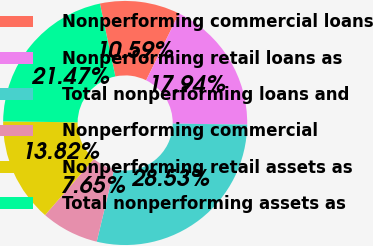Convert chart to OTSL. <chart><loc_0><loc_0><loc_500><loc_500><pie_chart><fcel>Nonperforming commercial loans<fcel>Nonperforming retail loans as<fcel>Total nonperforming loans and<fcel>Nonperforming commercial<fcel>Nonperforming retail assets as<fcel>Total nonperforming assets as<nl><fcel>10.59%<fcel>17.94%<fcel>28.53%<fcel>7.65%<fcel>13.82%<fcel>21.47%<nl></chart> 